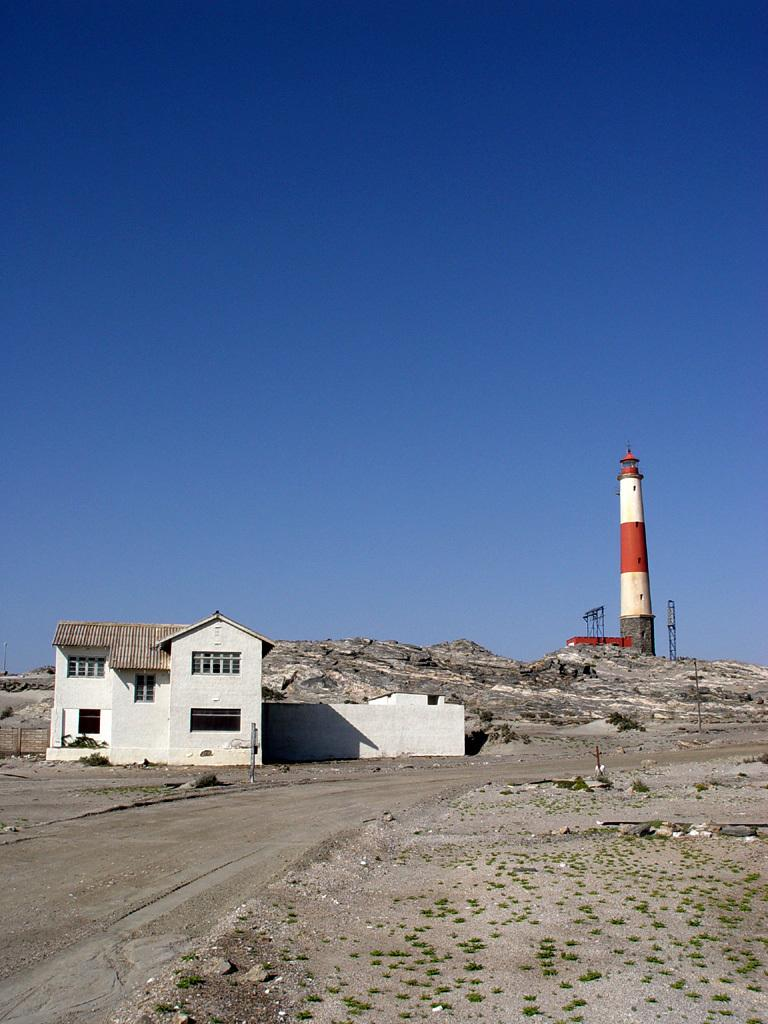What type of structure is present in the image? There is a building in the image. What other feature can be seen in the image? There is a tower in the image. What is visible at the bottom of the image? The ground is visible at the bottom of the image. What type of pen is being used to draw the tower in the image? There is no pen or drawing activity present in the image; it is a photograph of a building and a tower. 